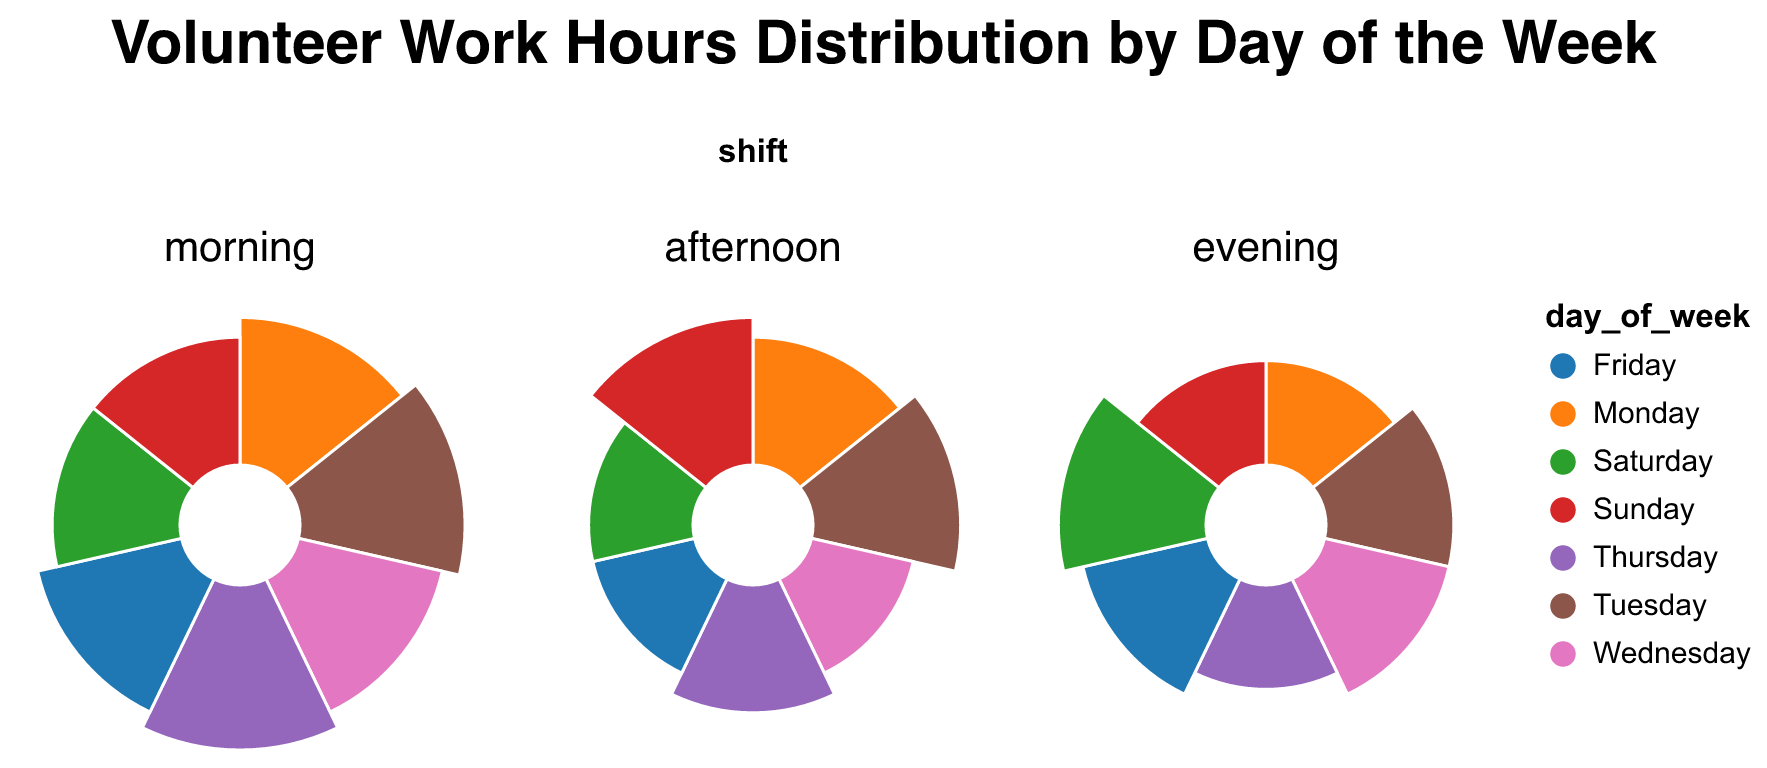What day has the highest total hours worked in the morning shift? To determine which day has the highest total hours worked in the morning shift, refer to the "morning" subplot. Sum up the hours worked for each day: 
- Monday: 4 hours
- Tuesday: 5 hours
- Wednesday: 4 hours
- Thursday: 5 hours
- Friday: 4 hours
- Saturday: 3 hours
- Sunday: 3 hours
Both Tuesday and Thursday have the highest at 5 hours.
Answer: Tuesday and Thursday Which shift has the lowest total hours worked on Saturday? To find out the shift with the lowest total hours worked on Saturday, look at the "Saturday" data in each subplot:
- Morning: 3 hours
- Afternoon: 2 hours
- Evening: 4 hours
The afternoon shift has the lowest total.
Answer: Afternoon What is the difference in hours worked in the evening shift between Monday and Saturday? To calculate the difference in hours worked in the evening shift between Monday and Saturday, check the "evening" subplot:
- Monday: 2 hours
- Saturday: 4 hours
The difference is 4 - 2 = 2 hours.
Answer: 2 hours Which volunteer worked the most hours on Sunday? To determine the volunteer who worked the most hours on Sunday, sum the hours worked by each volunteer in the Sunday segments of the subplots:
- John Doe: 3 hours (morning)
- Emily Chen: 4 hours (afternoon)
- Susan Clark: 2 hours (evening)
Emily Chen worked the most at 4 hours.
Answer: Emily Chen Which day of the week has the most varied shift distribution in terms of the number of hours worked? To identify the day with the most varied shift distribution (highest variability between shifts), observe each day's shift hours in every subplot:
- Monday: 4, 3, 2 hours
- Tuesday: 5, 4, 3 hours
- Wednesday: 4, 2, 3 hours
- Thursday: 5, 3, 2 hours
- Friday: 4, 2, 3 hours
- Saturday: 3, 2, 4 hours
- Sunday: 3, 4, 2 hours
The day with the most varied distribution is Monday with a spread of 4 - 2 = 2 hours.
Answer: Monday How many total hours did Michael Brown work in the entire week? To find out Michael Brown's total hours worked in the week, sum his hours from all shifts:
- Tuesday: 4 hours (afternoon)
- Thursday: 3 hours (afternoon)
- Saturday: 4 hours (evening)
Michael Brown's total is 4 + 3 + 4 = 11 hours.
Answer: 11 hours Which day has the most balanced distribution of work hours across all shifts? A balanced distribution means the hours worked in all shifts are close to each other in value. Check each day's shift hours:
- Monday: 4, 3, 2 hours
- Tuesday: 5, 4, 3 hours
- Wednesday: 4, 2, 3 hours
- Thursday: 5, 3, 2 hours
- Friday: 4, 2, 3 hours
- Saturday: 3, 2, 4 hours
- Sunday: 3, 4, 2 hours
Tuesday has the most balanced distribution (5, 4, 3 hours).
Answer: Tuesday Which volunteer's hours are most concentrated in the morning shift? To identify the volunteer whose work hours are most concentrated in the morning shift, sum each volunteer's hours worked in the morning:
- John Doe: 4 (Monday) + 4 (Wednesday) + 4 (Friday) + 3 (Sunday) = 15 hours
- Alice Johnson: 5 (Tuesday) + 5 (Thursday) + 3 (Saturday) = 13 hours
John Doe has the most concentrated hours in the morning shift at 15 hours.
Answer: John Doe 